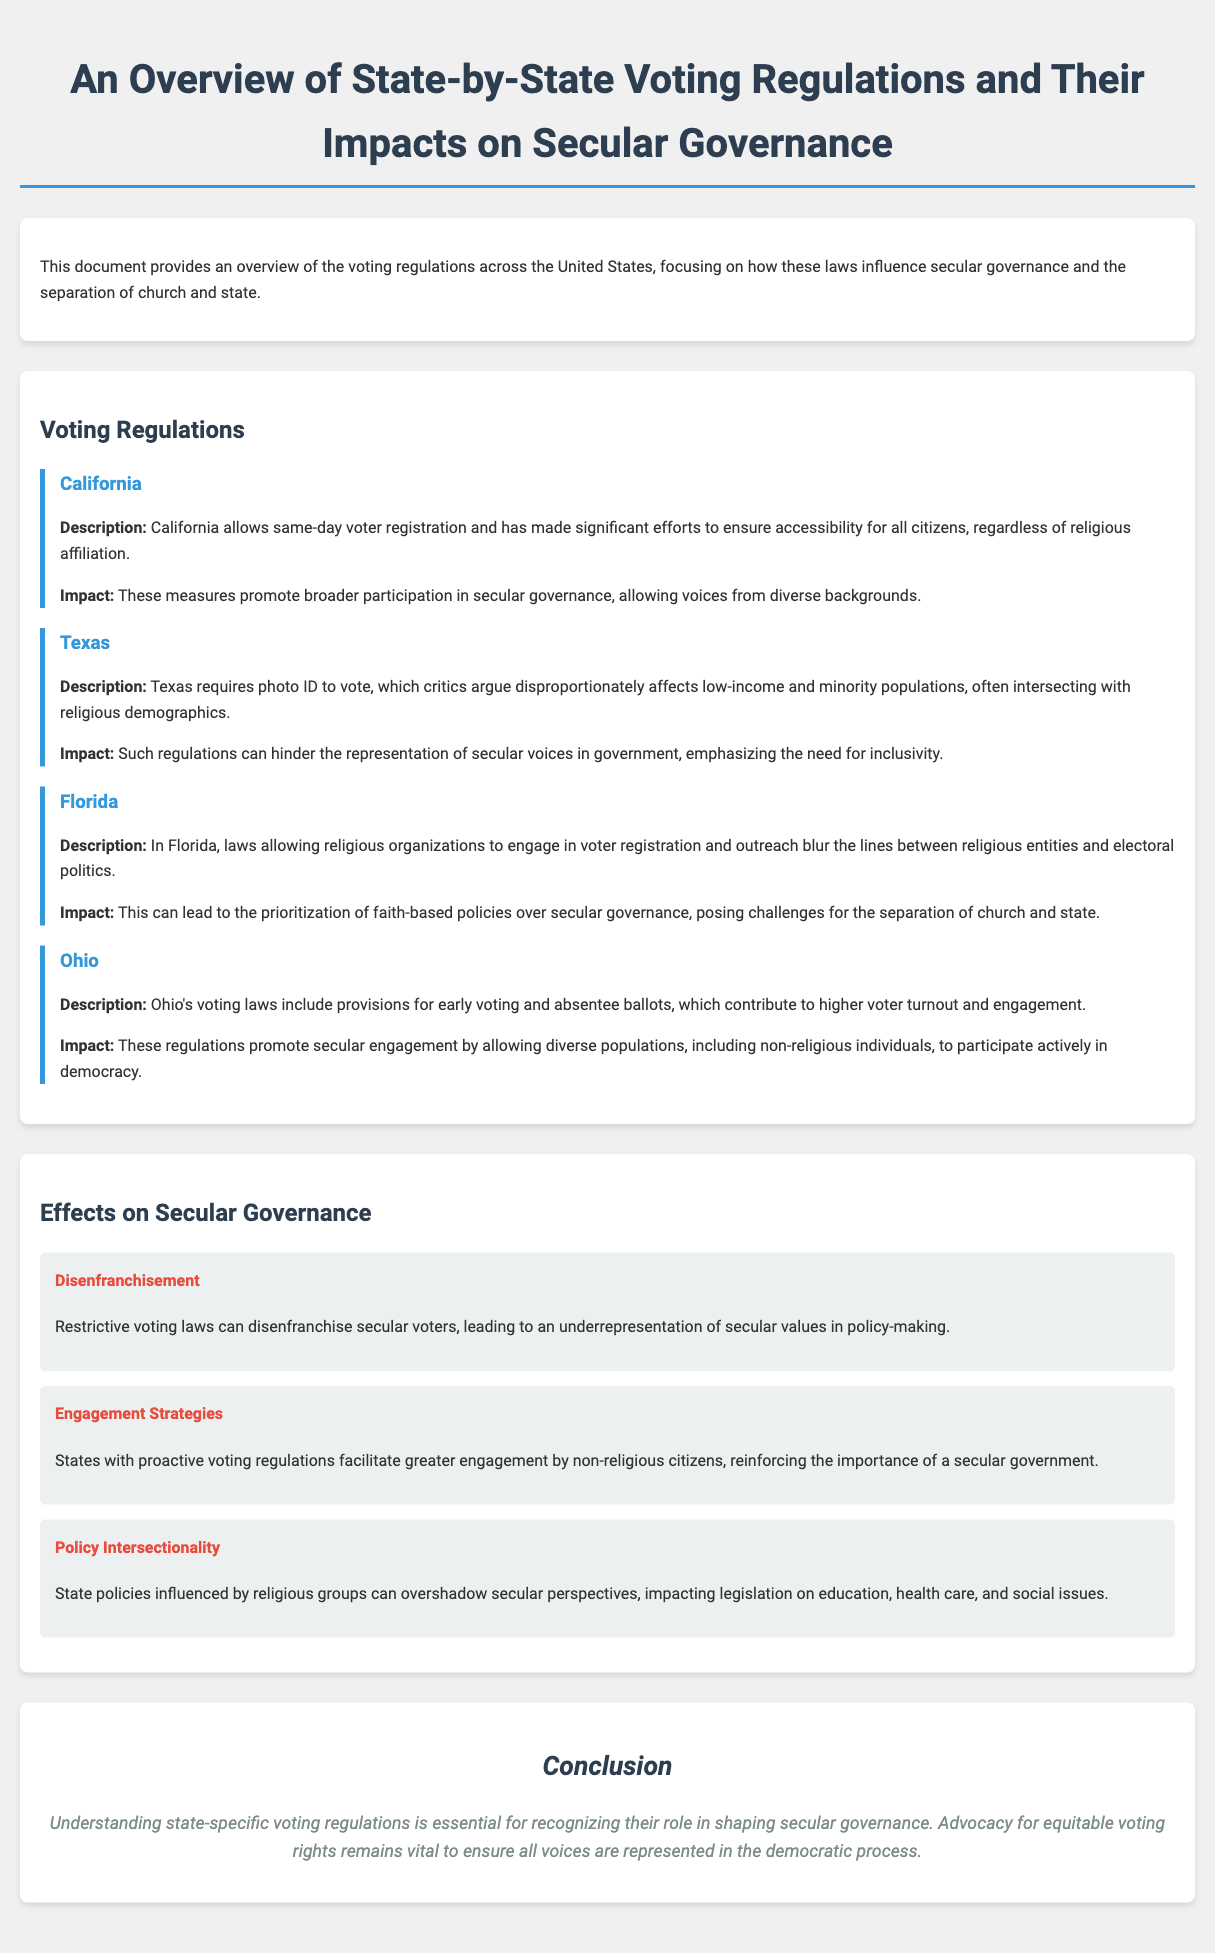what is the primary focus of the document? The document provides an overview of voting regulations and how they influence secular governance.
Answer: secular governance which state allows same-day voter registration? The document states that California allows same-day voter registration.
Answer: California what is a challenge posed by Florida's voting laws? Florida's laws blur the lines between religious entities and electoral politics.
Answer: blurring lines how do Ohio's voting laws contribute to voter turnout? Ohio's voting laws include provisions for early voting and absentee ballots, which promote higher turnout.
Answer: early voting and absentee ballots what can restrictive voting laws lead to according to the document? Restrictive voting laws can lead to disenfranchisement of secular voters.
Answer: disenfranchisement which state has voting regulations that critics argue affect low-income populations? Texas has regulations that disproportionately affect low-income and minority populations.
Answer: Texas what is one effect of proactive voting regulations? Proactive voting regulations facilitate greater engagement by non-religious citizens.
Answer: greater engagement how does the document suggest state policies influenced by religious groups impact legislation? Such policies can overshadow secular perspectives, impacting legislation.
Answer: overshadow secular perspectives what is the conclusion about voting rights? Advocacy for equitable voting rights is essential to ensure all voices are represented.
Answer: equitable voting rights 